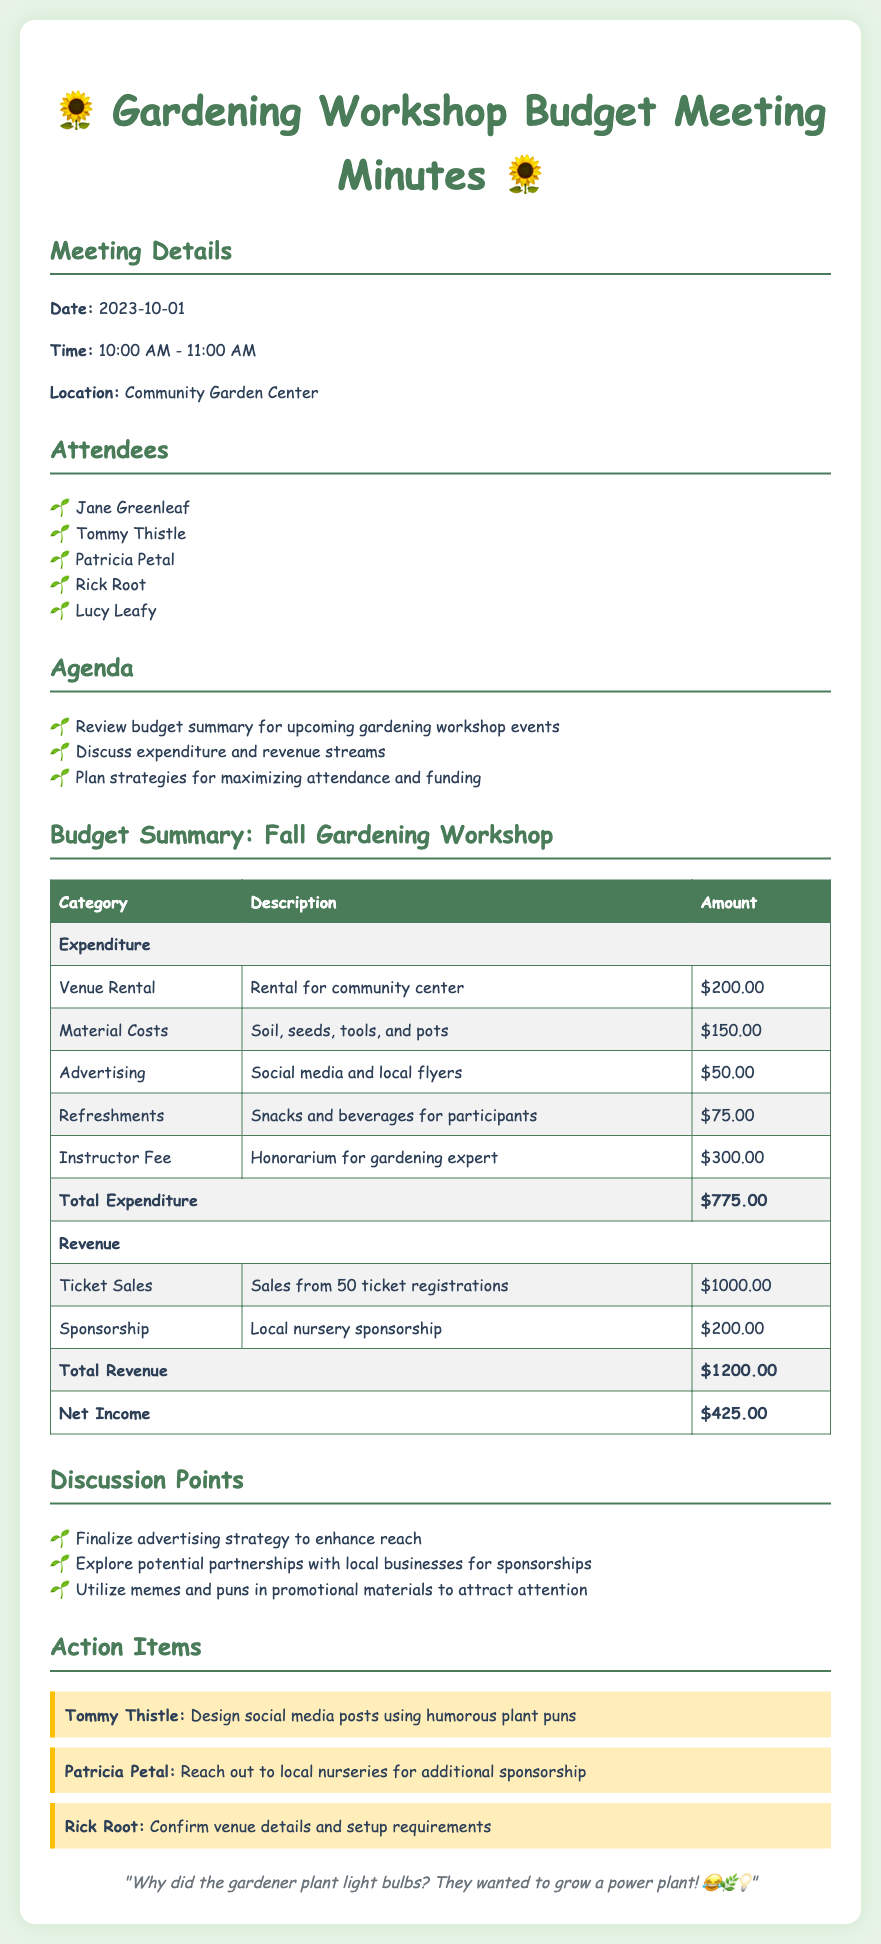What is the date of the meeting? The date of the meeting is explicitly mentioned in the document.
Answer: 2023-10-01 Who is the instructor for the workshop? The document specifies the instructor's fee but does not directly name an individual; it indicates the role.
Answer: Gardening expert What is the venue rental cost? The cost for renting the venue is outlined in the expenditure table of the document.
Answer: $200.00 What is the total net income from the workshop? The net income is calculated from total revenue minus total expenditure, as shown in the budget summary.
Answer: $425.00 What was the attendance for ticket sales? The document states the number of ticket registrations contributing to the ticket sales revenue.
Answer: 50 What is one strategy to enhance advertising? The meeting discusses finalizing an advertising strategy, emphasizing creativity in promoting the event.
Answer: Utilize memes and puns Who is responsible for designing social media posts? The action item section assigns a specific individual to handle social media designs.
Answer: Tommy Thistle What was the total expenditure for the workshop? The total expenditure summarizes all listed expenses related to the workshop in the budget section.
Answer: $775.00 What is the total revenue generated from sponsorship? The revenue section distinguishes between ticket sales and sponsorship, so this amount is specific to sponsorship.
Answer: $200.00 